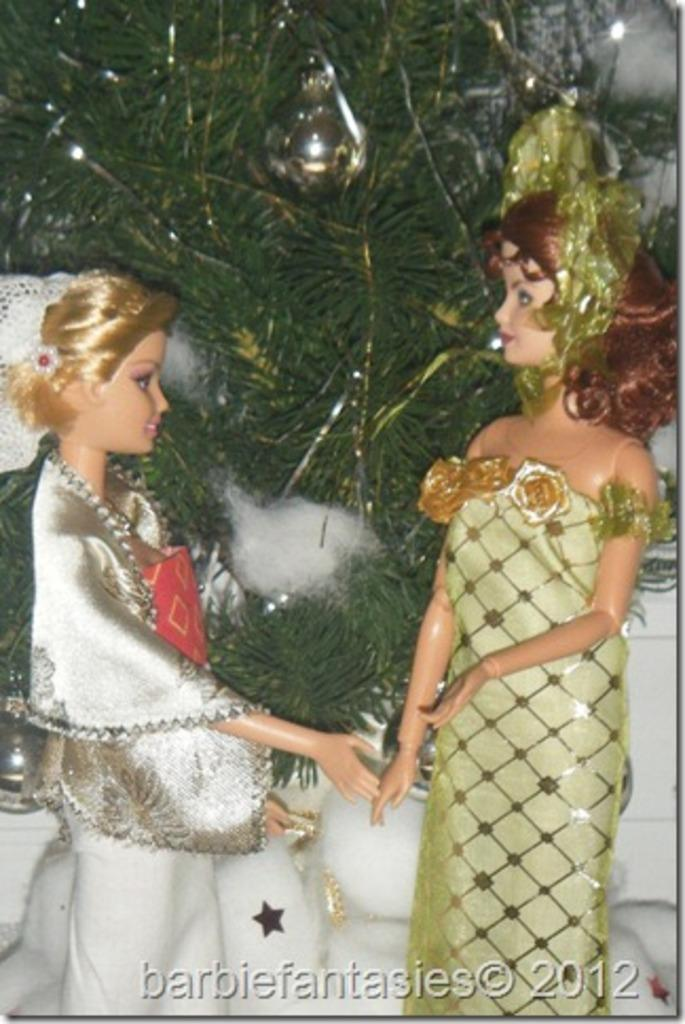What type of figures are present in the image? There are two dressed Barbie girls in the image. What can be seen in the background of the image? There are leaves visible in the background of the image. Is there any text present in the image? Yes, there is some text at the bottom of the image. Reasoning: Let'g: Let's think step by step in order to produce the conversation. We start by identifying the main subjects in the image, which are the two dressed Barbie girls. Then, we describe the background of the image, noting the presence of leaves. Finally, we mention the text at the bottom of the image. Each question is designed to elicit a specific detail about the image that is known from the provided facts. Absurd Question/Answer: What type of weather can be seen in the image? There is no weather depicted in the image; it is a still image of two dressed Barbie girls and leaves in the background. Do the Barbie girls express any regret in the image? There is no indication of regret in the image; it is a simple depiction of two dressed Barbie girls. What type of tool is being used by the Barbie girls in the image? There is no tool, such as a wrench, present in the image; it is a simple depiction of two dressed Barbie girls and leaves in the background. 